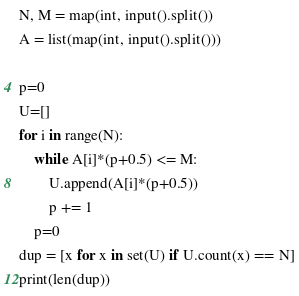<code> <loc_0><loc_0><loc_500><loc_500><_Python_>N, M = map(int, input().split())
A = list(map(int, input().split()))

p=0
U=[]
for i in range(N):
    while A[i]*(p+0.5) <= M:
        U.append(A[i]*(p+0.5))
        p += 1
    p=0
dup = [x for x in set(U) if U.count(x) == N]
print(len(dup))
</code> 